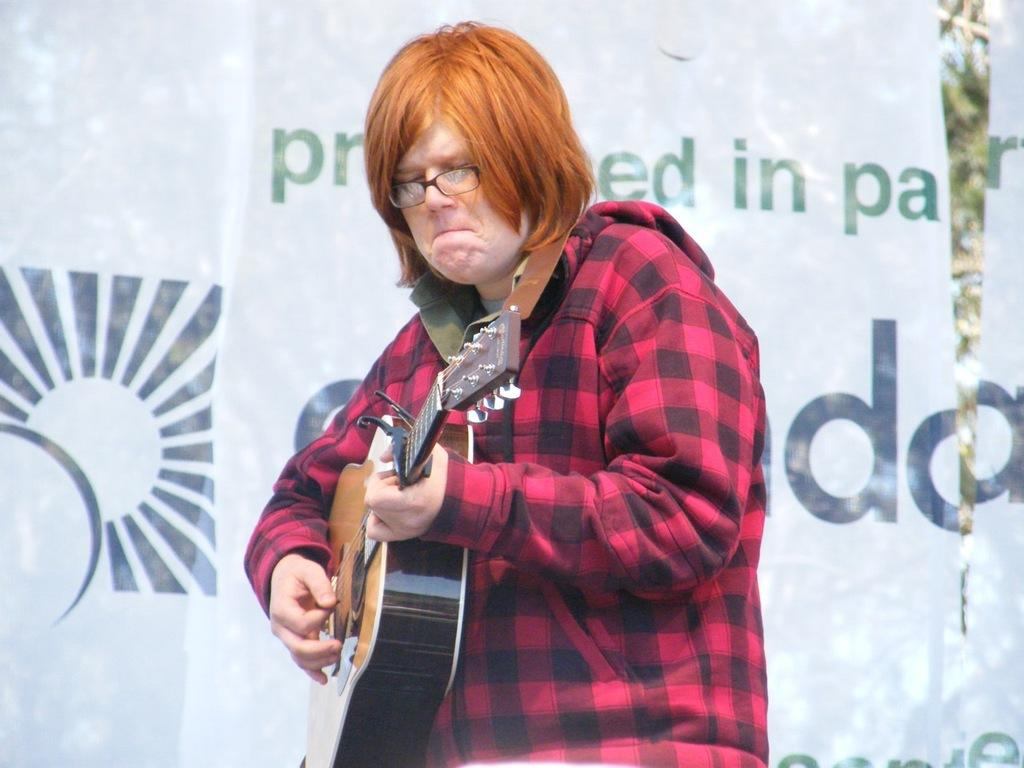What is the person in the image doing? The person is playing the guitar. What object is the person holding while playing the guitar? The person is holding a guitar. What can be seen in the background of the image? There is a banner in the background of the image. How many eggs are being carried by the horses in the image? There are no horses or eggs present in the image. What type of cent is depicted on the banner in the image? The banner in the image does not feature any cent or currency symbol. 